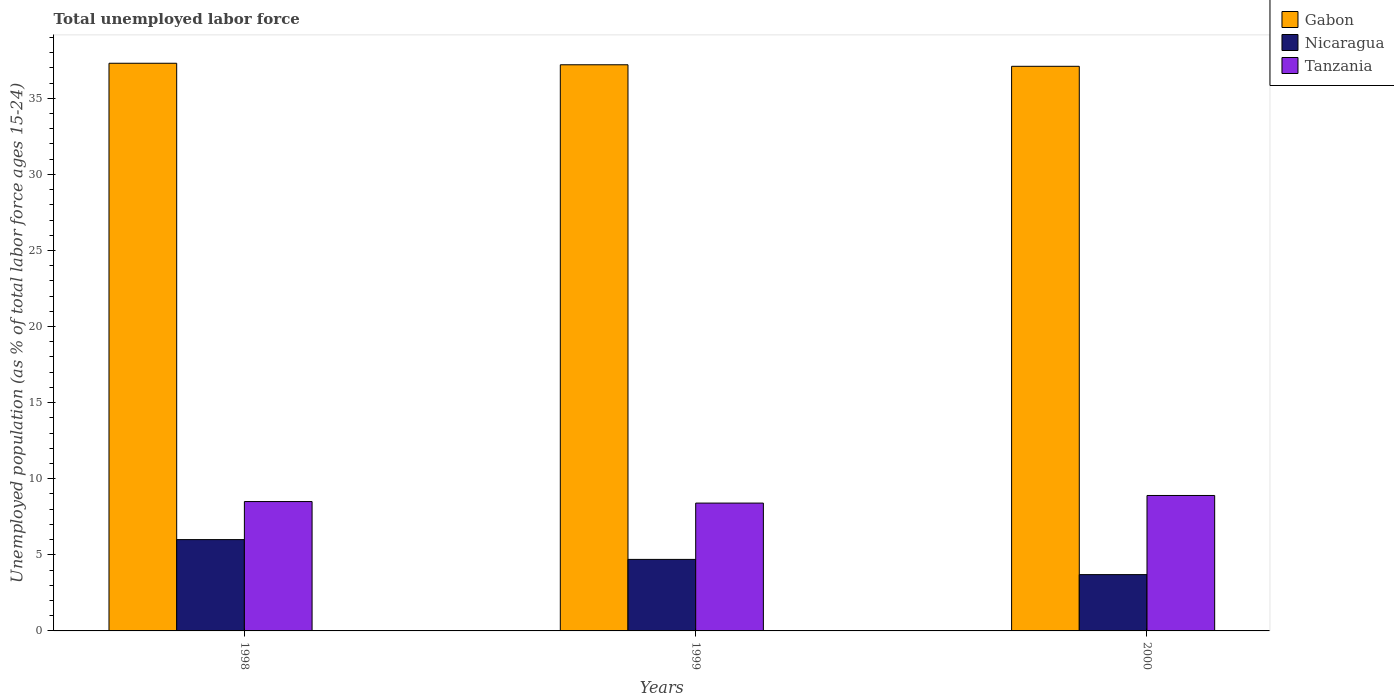How many different coloured bars are there?
Your answer should be compact. 3. Are the number of bars on each tick of the X-axis equal?
Keep it short and to the point. Yes. How many bars are there on the 2nd tick from the left?
Your answer should be compact. 3. How many bars are there on the 2nd tick from the right?
Make the answer very short. 3. What is the percentage of unemployed population in in Gabon in 1998?
Offer a very short reply. 37.3. Across all years, what is the minimum percentage of unemployed population in in Tanzania?
Your answer should be very brief. 8.4. In which year was the percentage of unemployed population in in Nicaragua maximum?
Offer a terse response. 1998. What is the total percentage of unemployed population in in Tanzania in the graph?
Your answer should be compact. 25.8. What is the difference between the percentage of unemployed population in in Gabon in 1999 and that in 2000?
Keep it short and to the point. 0.1. What is the difference between the percentage of unemployed population in in Nicaragua in 2000 and the percentage of unemployed population in in Tanzania in 1998?
Keep it short and to the point. -4.8. What is the average percentage of unemployed population in in Gabon per year?
Offer a very short reply. 37.2. In the year 1999, what is the difference between the percentage of unemployed population in in Gabon and percentage of unemployed population in in Tanzania?
Your answer should be compact. 28.8. What is the ratio of the percentage of unemployed population in in Gabon in 1998 to that in 1999?
Offer a very short reply. 1. Is the percentage of unemployed population in in Gabon in 1998 less than that in 2000?
Ensure brevity in your answer.  No. Is the difference between the percentage of unemployed population in in Gabon in 1998 and 2000 greater than the difference between the percentage of unemployed population in in Tanzania in 1998 and 2000?
Your answer should be compact. Yes. What is the difference between the highest and the second highest percentage of unemployed population in in Gabon?
Offer a very short reply. 0.1. What is the difference between the highest and the lowest percentage of unemployed population in in Gabon?
Your answer should be very brief. 0.2. In how many years, is the percentage of unemployed population in in Tanzania greater than the average percentage of unemployed population in in Tanzania taken over all years?
Your response must be concise. 1. What does the 3rd bar from the left in 2000 represents?
Your response must be concise. Tanzania. What does the 3rd bar from the right in 1999 represents?
Your answer should be very brief. Gabon. Is it the case that in every year, the sum of the percentage of unemployed population in in Tanzania and percentage of unemployed population in in Nicaragua is greater than the percentage of unemployed population in in Gabon?
Your response must be concise. No. Are all the bars in the graph horizontal?
Ensure brevity in your answer.  No. How many years are there in the graph?
Keep it short and to the point. 3. What is the difference between two consecutive major ticks on the Y-axis?
Keep it short and to the point. 5. Does the graph contain any zero values?
Your answer should be very brief. No. Does the graph contain grids?
Your answer should be compact. No. Where does the legend appear in the graph?
Your response must be concise. Top right. What is the title of the graph?
Your answer should be very brief. Total unemployed labor force. What is the label or title of the Y-axis?
Provide a succinct answer. Unemployed population (as % of total labor force ages 15-24). What is the Unemployed population (as % of total labor force ages 15-24) in Gabon in 1998?
Provide a succinct answer. 37.3. What is the Unemployed population (as % of total labor force ages 15-24) in Tanzania in 1998?
Give a very brief answer. 8.5. What is the Unemployed population (as % of total labor force ages 15-24) of Gabon in 1999?
Ensure brevity in your answer.  37.2. What is the Unemployed population (as % of total labor force ages 15-24) in Nicaragua in 1999?
Keep it short and to the point. 4.7. What is the Unemployed population (as % of total labor force ages 15-24) of Tanzania in 1999?
Ensure brevity in your answer.  8.4. What is the Unemployed population (as % of total labor force ages 15-24) of Gabon in 2000?
Offer a very short reply. 37.1. What is the Unemployed population (as % of total labor force ages 15-24) of Nicaragua in 2000?
Offer a terse response. 3.7. What is the Unemployed population (as % of total labor force ages 15-24) in Tanzania in 2000?
Offer a terse response. 8.9. Across all years, what is the maximum Unemployed population (as % of total labor force ages 15-24) in Gabon?
Ensure brevity in your answer.  37.3. Across all years, what is the maximum Unemployed population (as % of total labor force ages 15-24) of Tanzania?
Offer a terse response. 8.9. Across all years, what is the minimum Unemployed population (as % of total labor force ages 15-24) in Gabon?
Your answer should be compact. 37.1. Across all years, what is the minimum Unemployed population (as % of total labor force ages 15-24) of Nicaragua?
Make the answer very short. 3.7. Across all years, what is the minimum Unemployed population (as % of total labor force ages 15-24) of Tanzania?
Offer a terse response. 8.4. What is the total Unemployed population (as % of total labor force ages 15-24) of Gabon in the graph?
Your answer should be very brief. 111.6. What is the total Unemployed population (as % of total labor force ages 15-24) in Nicaragua in the graph?
Offer a terse response. 14.4. What is the total Unemployed population (as % of total labor force ages 15-24) of Tanzania in the graph?
Give a very brief answer. 25.8. What is the difference between the Unemployed population (as % of total labor force ages 15-24) in Nicaragua in 1998 and that in 1999?
Give a very brief answer. 1.3. What is the difference between the Unemployed population (as % of total labor force ages 15-24) in Gabon in 1998 and that in 2000?
Keep it short and to the point. 0.2. What is the difference between the Unemployed population (as % of total labor force ages 15-24) in Nicaragua in 1998 and that in 2000?
Provide a short and direct response. 2.3. What is the difference between the Unemployed population (as % of total labor force ages 15-24) in Gabon in 1999 and that in 2000?
Provide a succinct answer. 0.1. What is the difference between the Unemployed population (as % of total labor force ages 15-24) of Tanzania in 1999 and that in 2000?
Provide a succinct answer. -0.5. What is the difference between the Unemployed population (as % of total labor force ages 15-24) of Gabon in 1998 and the Unemployed population (as % of total labor force ages 15-24) of Nicaragua in 1999?
Provide a succinct answer. 32.6. What is the difference between the Unemployed population (as % of total labor force ages 15-24) in Gabon in 1998 and the Unemployed population (as % of total labor force ages 15-24) in Tanzania in 1999?
Your answer should be very brief. 28.9. What is the difference between the Unemployed population (as % of total labor force ages 15-24) in Gabon in 1998 and the Unemployed population (as % of total labor force ages 15-24) in Nicaragua in 2000?
Make the answer very short. 33.6. What is the difference between the Unemployed population (as % of total labor force ages 15-24) in Gabon in 1998 and the Unemployed population (as % of total labor force ages 15-24) in Tanzania in 2000?
Your answer should be very brief. 28.4. What is the difference between the Unemployed population (as % of total labor force ages 15-24) of Nicaragua in 1998 and the Unemployed population (as % of total labor force ages 15-24) of Tanzania in 2000?
Your answer should be compact. -2.9. What is the difference between the Unemployed population (as % of total labor force ages 15-24) in Gabon in 1999 and the Unemployed population (as % of total labor force ages 15-24) in Nicaragua in 2000?
Your answer should be compact. 33.5. What is the difference between the Unemployed population (as % of total labor force ages 15-24) of Gabon in 1999 and the Unemployed population (as % of total labor force ages 15-24) of Tanzania in 2000?
Provide a short and direct response. 28.3. What is the average Unemployed population (as % of total labor force ages 15-24) of Gabon per year?
Give a very brief answer. 37.2. In the year 1998, what is the difference between the Unemployed population (as % of total labor force ages 15-24) in Gabon and Unemployed population (as % of total labor force ages 15-24) in Nicaragua?
Your answer should be compact. 31.3. In the year 1998, what is the difference between the Unemployed population (as % of total labor force ages 15-24) of Gabon and Unemployed population (as % of total labor force ages 15-24) of Tanzania?
Offer a very short reply. 28.8. In the year 1999, what is the difference between the Unemployed population (as % of total labor force ages 15-24) of Gabon and Unemployed population (as % of total labor force ages 15-24) of Nicaragua?
Make the answer very short. 32.5. In the year 1999, what is the difference between the Unemployed population (as % of total labor force ages 15-24) in Gabon and Unemployed population (as % of total labor force ages 15-24) in Tanzania?
Offer a very short reply. 28.8. In the year 1999, what is the difference between the Unemployed population (as % of total labor force ages 15-24) of Nicaragua and Unemployed population (as % of total labor force ages 15-24) of Tanzania?
Keep it short and to the point. -3.7. In the year 2000, what is the difference between the Unemployed population (as % of total labor force ages 15-24) of Gabon and Unemployed population (as % of total labor force ages 15-24) of Nicaragua?
Provide a short and direct response. 33.4. In the year 2000, what is the difference between the Unemployed population (as % of total labor force ages 15-24) of Gabon and Unemployed population (as % of total labor force ages 15-24) of Tanzania?
Offer a terse response. 28.2. In the year 2000, what is the difference between the Unemployed population (as % of total labor force ages 15-24) of Nicaragua and Unemployed population (as % of total labor force ages 15-24) of Tanzania?
Make the answer very short. -5.2. What is the ratio of the Unemployed population (as % of total labor force ages 15-24) of Gabon in 1998 to that in 1999?
Keep it short and to the point. 1. What is the ratio of the Unemployed population (as % of total labor force ages 15-24) in Nicaragua in 1998 to that in 1999?
Give a very brief answer. 1.28. What is the ratio of the Unemployed population (as % of total labor force ages 15-24) in Tanzania in 1998 to that in 1999?
Your answer should be compact. 1.01. What is the ratio of the Unemployed population (as % of total labor force ages 15-24) in Gabon in 1998 to that in 2000?
Offer a terse response. 1.01. What is the ratio of the Unemployed population (as % of total labor force ages 15-24) in Nicaragua in 1998 to that in 2000?
Keep it short and to the point. 1.62. What is the ratio of the Unemployed population (as % of total labor force ages 15-24) of Tanzania in 1998 to that in 2000?
Provide a short and direct response. 0.96. What is the ratio of the Unemployed population (as % of total labor force ages 15-24) in Nicaragua in 1999 to that in 2000?
Your response must be concise. 1.27. What is the ratio of the Unemployed population (as % of total labor force ages 15-24) in Tanzania in 1999 to that in 2000?
Offer a very short reply. 0.94. What is the difference between the highest and the second highest Unemployed population (as % of total labor force ages 15-24) of Gabon?
Offer a very short reply. 0.1. What is the difference between the highest and the lowest Unemployed population (as % of total labor force ages 15-24) of Gabon?
Your response must be concise. 0.2. 